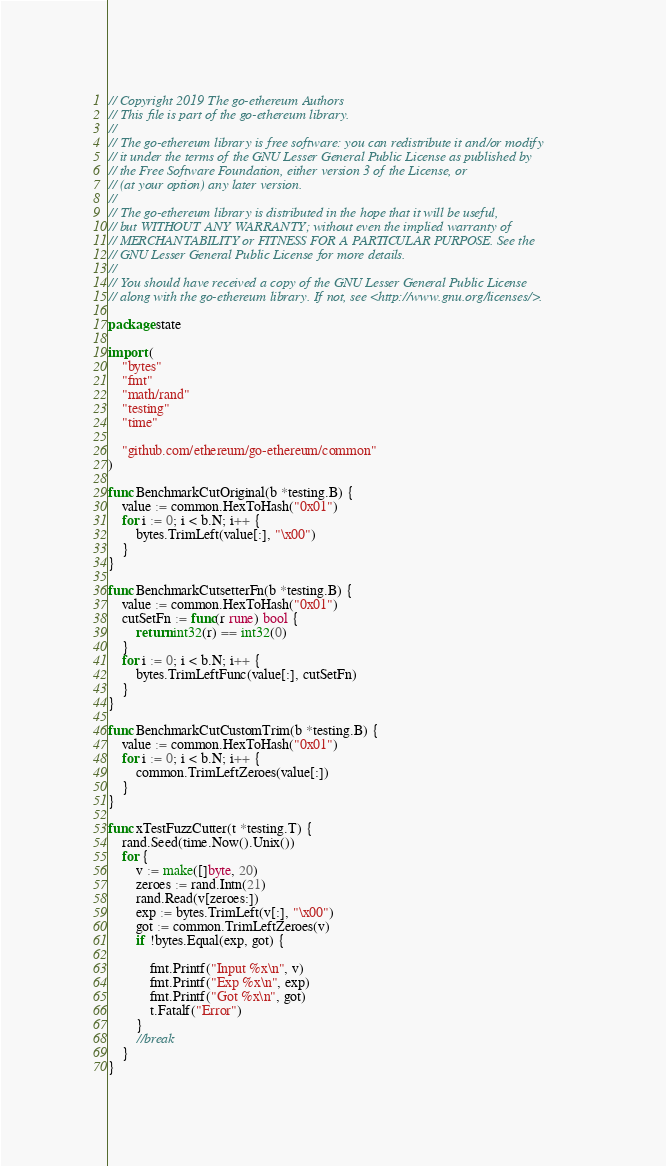<code> <loc_0><loc_0><loc_500><loc_500><_Go_>// Copyright 2019 The go-ethereum Authors
// This file is part of the go-ethereum library.
//
// The go-ethereum library is free software: you can redistribute it and/or modify
// it under the terms of the GNU Lesser General Public License as published by
// the Free Software Foundation, either version 3 of the License, or
// (at your option) any later version.
//
// The go-ethereum library is distributed in the hope that it will be useful,
// but WITHOUT ANY WARRANTY; without even the implied warranty of
// MERCHANTABILITY or FITNESS FOR A PARTICULAR PURPOSE. See the
// GNU Lesser General Public License for more details.
//
// You should have received a copy of the GNU Lesser General Public License
// along with the go-ethereum library. If not, see <http://www.gnu.org/licenses/>.

package state

import (
	"bytes"
	"fmt"
	"math/rand"
	"testing"
	"time"

	"github.com/ethereum/go-ethereum/common"
)

func BenchmarkCutOriginal(b *testing.B) {
	value := common.HexToHash("0x01")
	for i := 0; i < b.N; i++ {
		bytes.TrimLeft(value[:], "\x00")
	}
}

func BenchmarkCutsetterFn(b *testing.B) {
	value := common.HexToHash("0x01")
	cutSetFn := func(r rune) bool {
		return int32(r) == int32(0)
	}
	for i := 0; i < b.N; i++ {
		bytes.TrimLeftFunc(value[:], cutSetFn)
	}
}

func BenchmarkCutCustomTrim(b *testing.B) {
	value := common.HexToHash("0x01")
	for i := 0; i < b.N; i++ {
		common.TrimLeftZeroes(value[:])
	}
}

func xTestFuzzCutter(t *testing.T) {
	rand.Seed(time.Now().Unix())
	for {
		v := make([]byte, 20)
		zeroes := rand.Intn(21)
		rand.Read(v[zeroes:])
		exp := bytes.TrimLeft(v[:], "\x00")
		got := common.TrimLeftZeroes(v)
		if !bytes.Equal(exp, got) {

			fmt.Printf("Input %x\n", v)
			fmt.Printf("Exp %x\n", exp)
			fmt.Printf("Got %x\n", got)
			t.Fatalf("Error")
		}
		//break
	}
}
</code> 